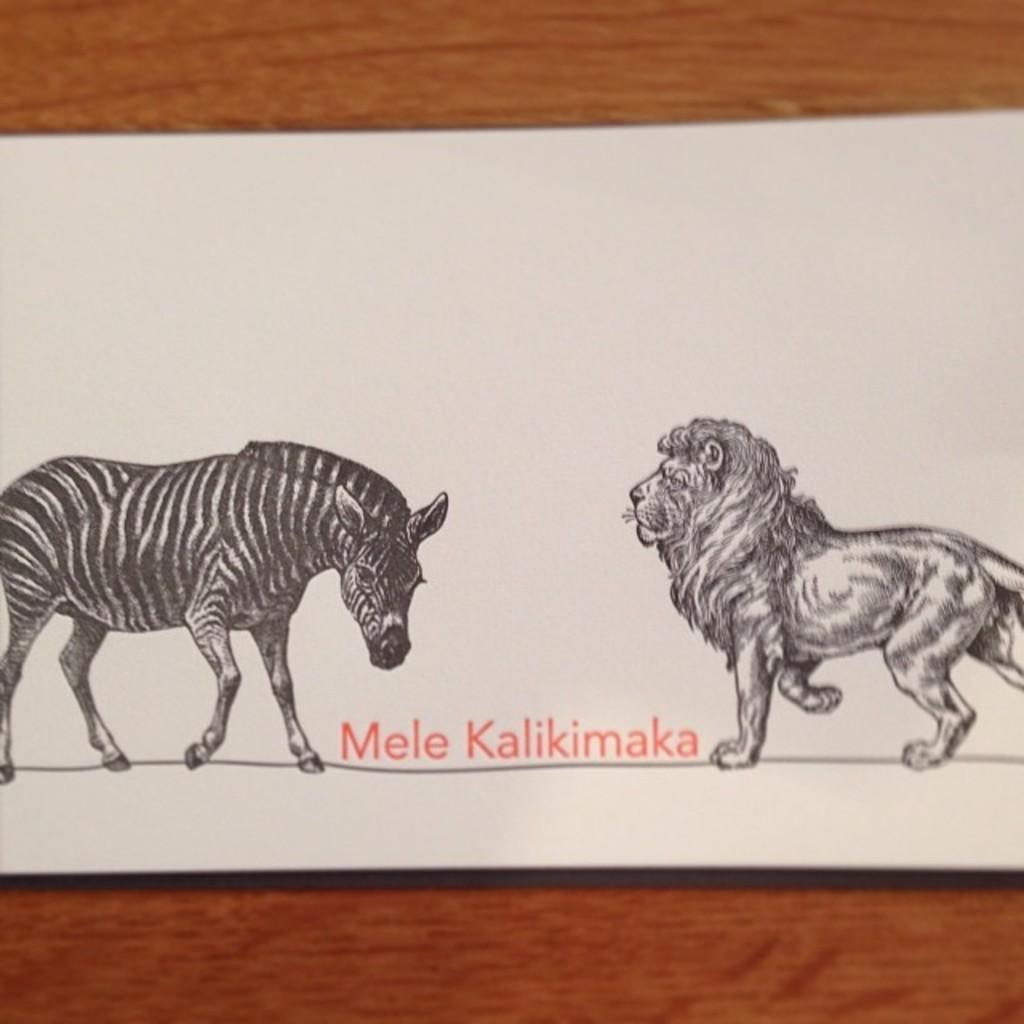What can be seen in the image related to animals? There are prints of two animals in the image. What else is present in the image besides the animal prints? There is writing on a board in the image. Can you describe the surface on which the board is placed? The board is on a brown color surface. What type of muscle is being exercised by the animals in the image? There are no animals present in the image, only prints of animals. Additionally, muscles are not exercised by prints, so this question is not relevant to the image. 